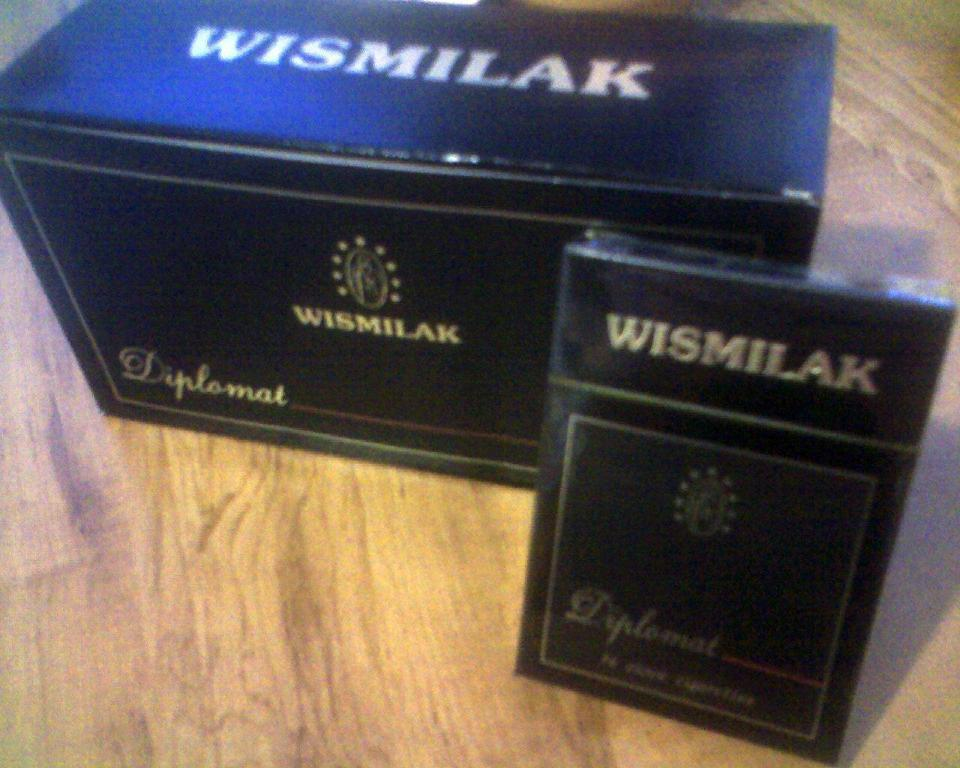<image>
Create a compact narrative representing the image presented. The brand of the black box is Wismilak 